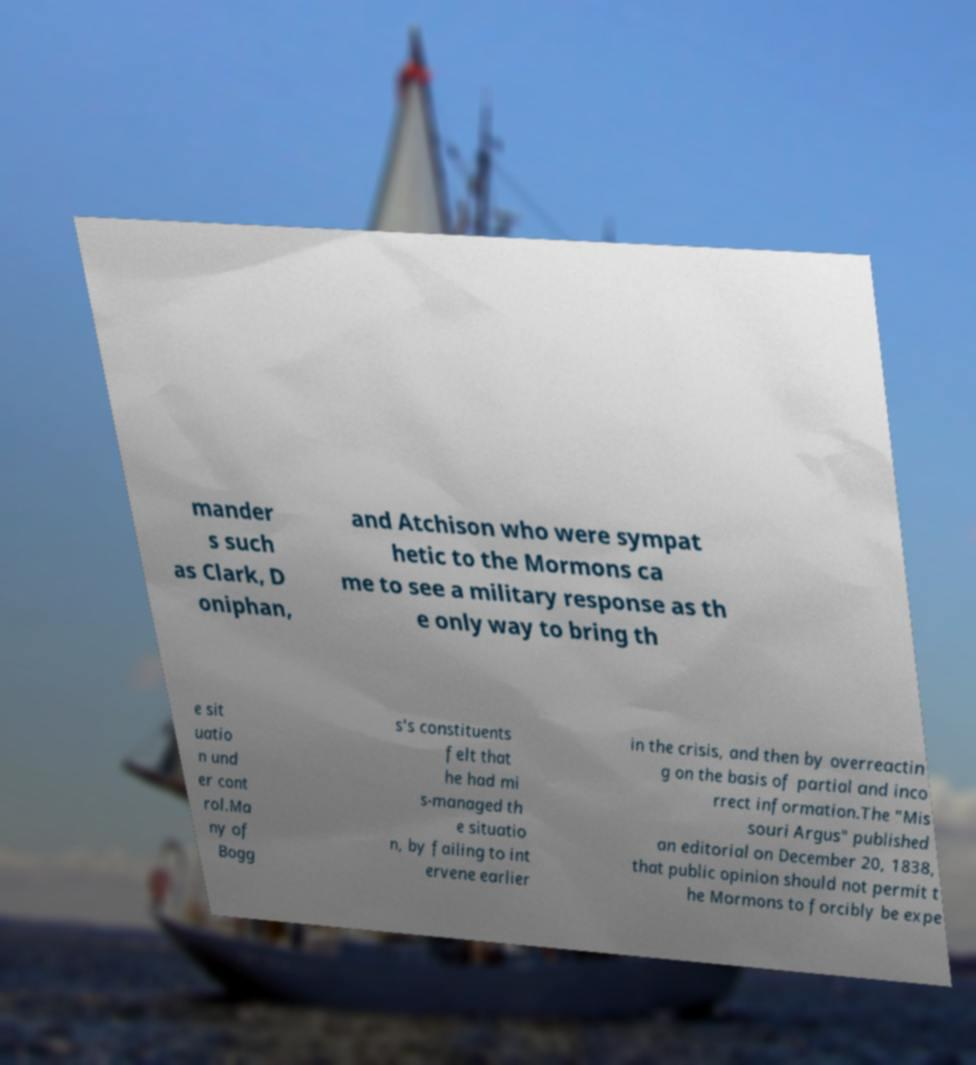Can you accurately transcribe the text from the provided image for me? mander s such as Clark, D oniphan, and Atchison who were sympat hetic to the Mormons ca me to see a military response as th e only way to bring th e sit uatio n und er cont rol.Ma ny of Bogg s's constituents felt that he had mi s-managed th e situatio n, by failing to int ervene earlier in the crisis, and then by overreactin g on the basis of partial and inco rrect information.The "Mis souri Argus" published an editorial on December 20, 1838, that public opinion should not permit t he Mormons to forcibly be expe 